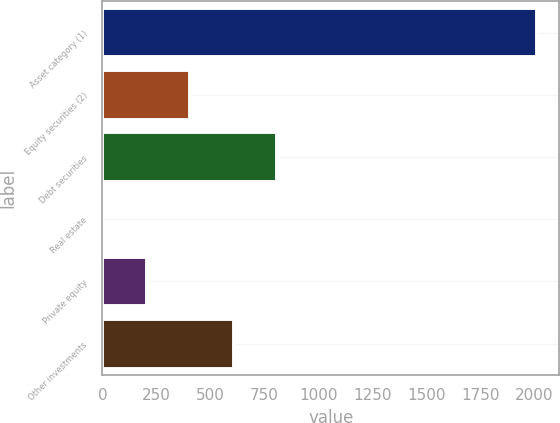<chart> <loc_0><loc_0><loc_500><loc_500><bar_chart><fcel>Asset category (1)<fcel>Equity securities (2)<fcel>Debt securities<fcel>Real estate<fcel>Private equity<fcel>Other investments<nl><fcel>2014<fcel>406<fcel>808<fcel>4<fcel>205<fcel>607<nl></chart> 